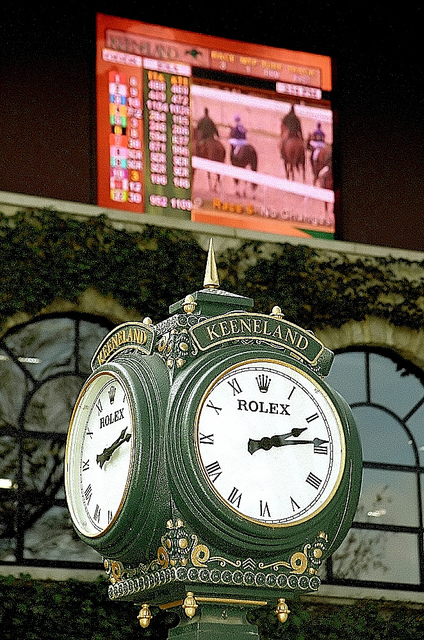<image>What baseball team is highlighted here? There is no baseball team highlighted. It can be horse racing, white sox, astros, yankees, or giants. What kind of bird is the team named after? I don't know what kind of bird the team is named after. It could be a robin, cardinal, or oriole. What baseball team is highlighted here? I don't know which baseball team is highlighted here. It can be the White Sox, the Astros, the Yankees, or the Giants. What kind of bird is the team named after? I don't know what kind of bird the team is named after. It can be either robin or cardinal. 